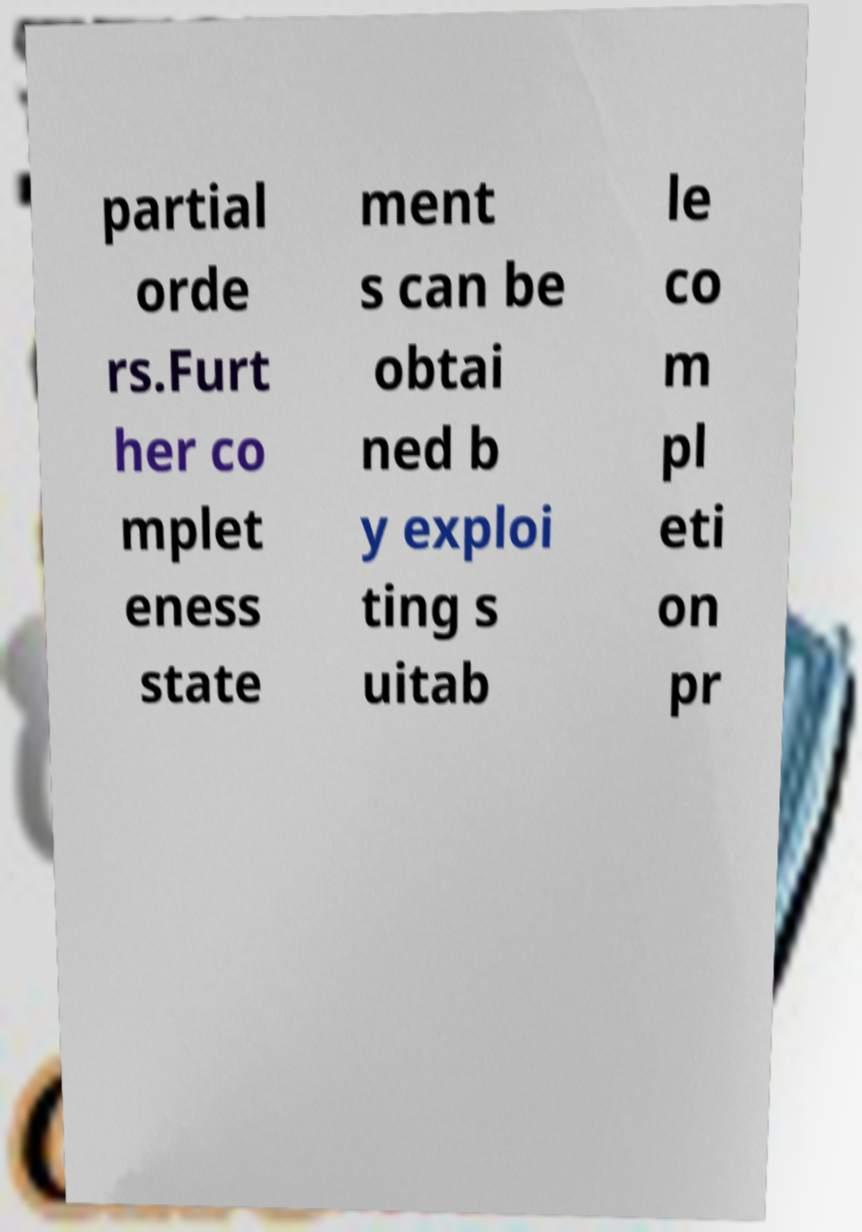Could you assist in decoding the text presented in this image and type it out clearly? partial orde rs.Furt her co mplet eness state ment s can be obtai ned b y exploi ting s uitab le co m pl eti on pr 